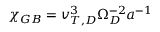Convert formula to latex. <formula><loc_0><loc_0><loc_500><loc_500>\chi _ { G B } = v _ { T , D } ^ { 3 } \Omega _ { D } ^ { - 2 } a ^ { - 1 }</formula> 